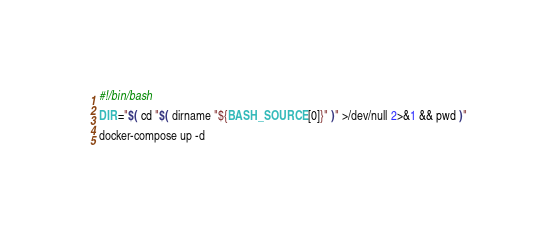Convert code to text. <code><loc_0><loc_0><loc_500><loc_500><_Bash_>#!/bin/bash

DIR="$( cd "$( dirname "${BASH_SOURCE[0]}" )" >/dev/null 2>&1 && pwd )"

docker-compose up -d
</code> 